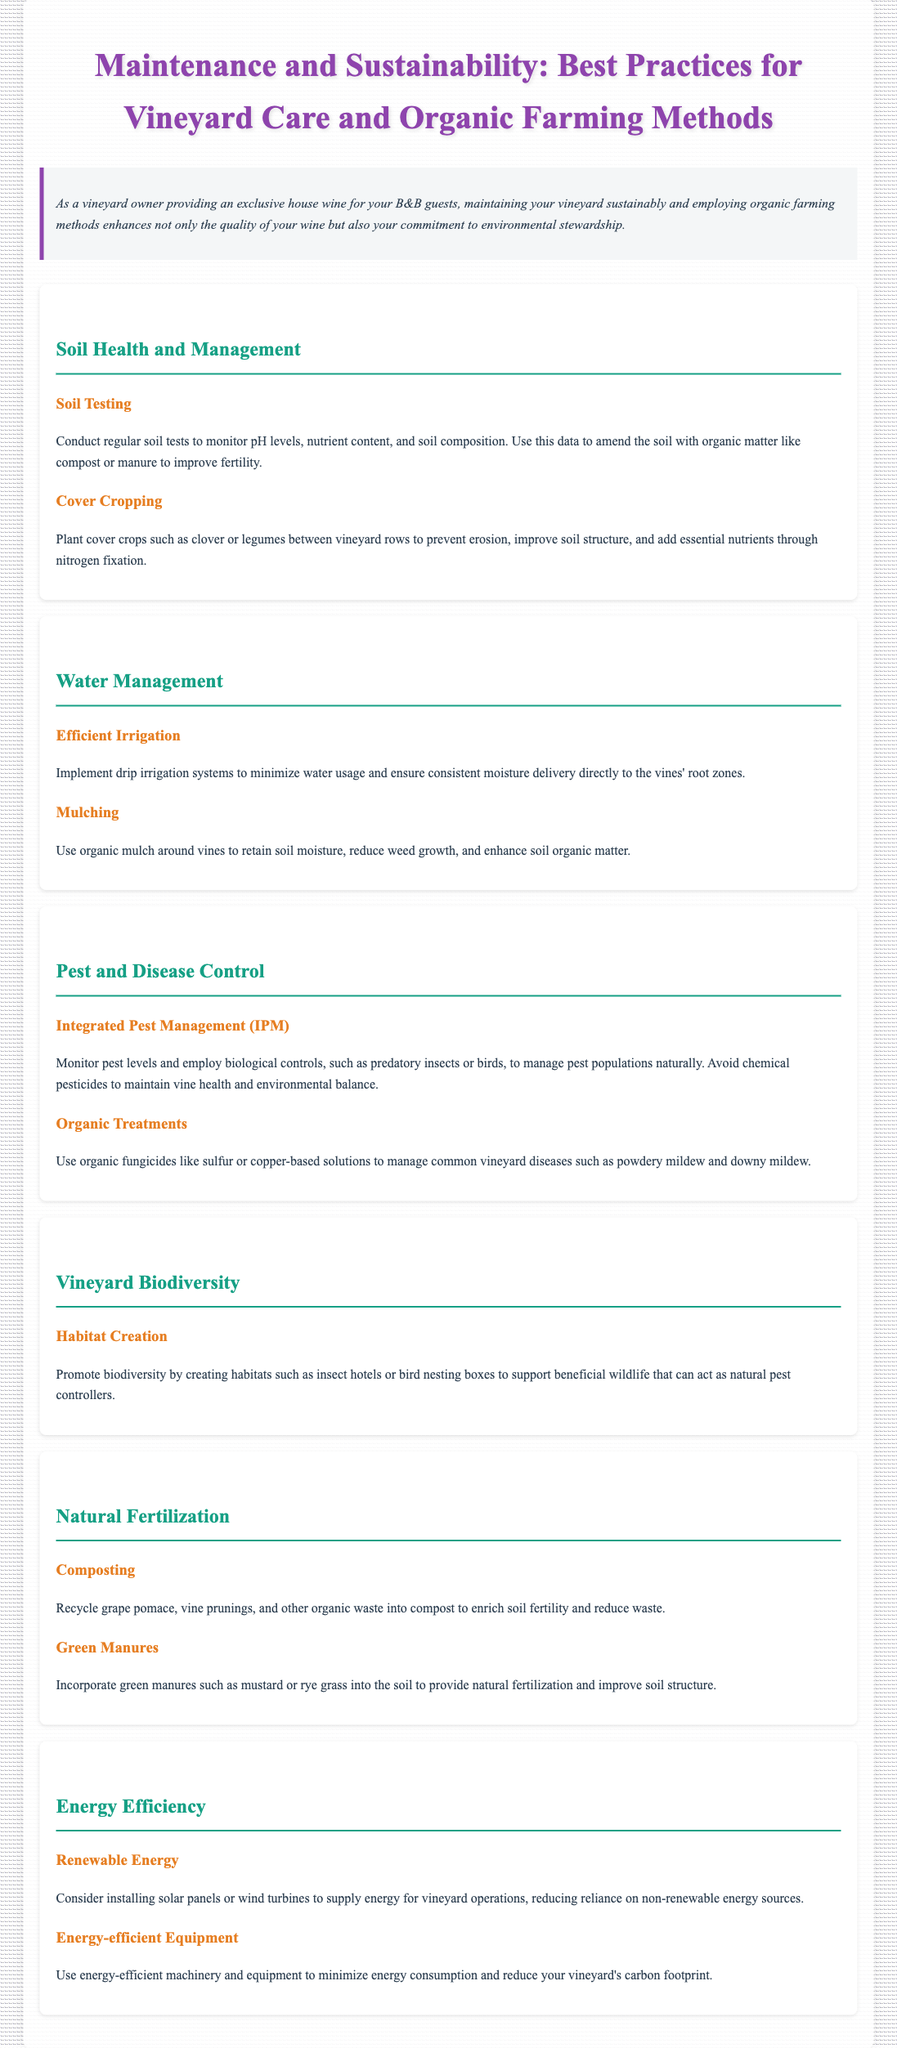What is the primary focus of this guide? The guide primarily focuses on best practices for maintaining a vineyard sustainably and employing organic farming methods.
Answer: Best practices for vineyard care and organic farming methods How can soil health be monitored? Soil health can be monitored by conducting regular soil tests to check pH levels and nutrient content.
Answer: Regular soil tests What is one method mentioned for effective irrigation? Drip irrigation systems are mentioned as a method to minimize water usage.
Answer: Drip irrigation systems What type of mulch is recommended around vines? Organic mulch is recommended to retain soil moisture and reduce weed growth.
Answer: Organic mulch What is the purpose of creating habitats in the vineyard? Creating habitats supports beneficial wildlife that can act as natural pest controllers.
Answer: Natural pest controllers Which organic treatment is suggested for managing powdery mildew? Organic fungicides like sulfur or copper-based solutions are suggested.
Answer: Sulfur or copper-based solutions Which renewable energy sources are mentioned for vineyard operations? Solar panels and wind turbines are mentioned as renewable energy sources.
Answer: Solar panels or wind turbines What should be recycled into compost for soil enrichment? Grape pomace, vine prunings, and other organic waste should be recycled into compost.
Answer: Grape pomace, vine prunings, and other organic waste 